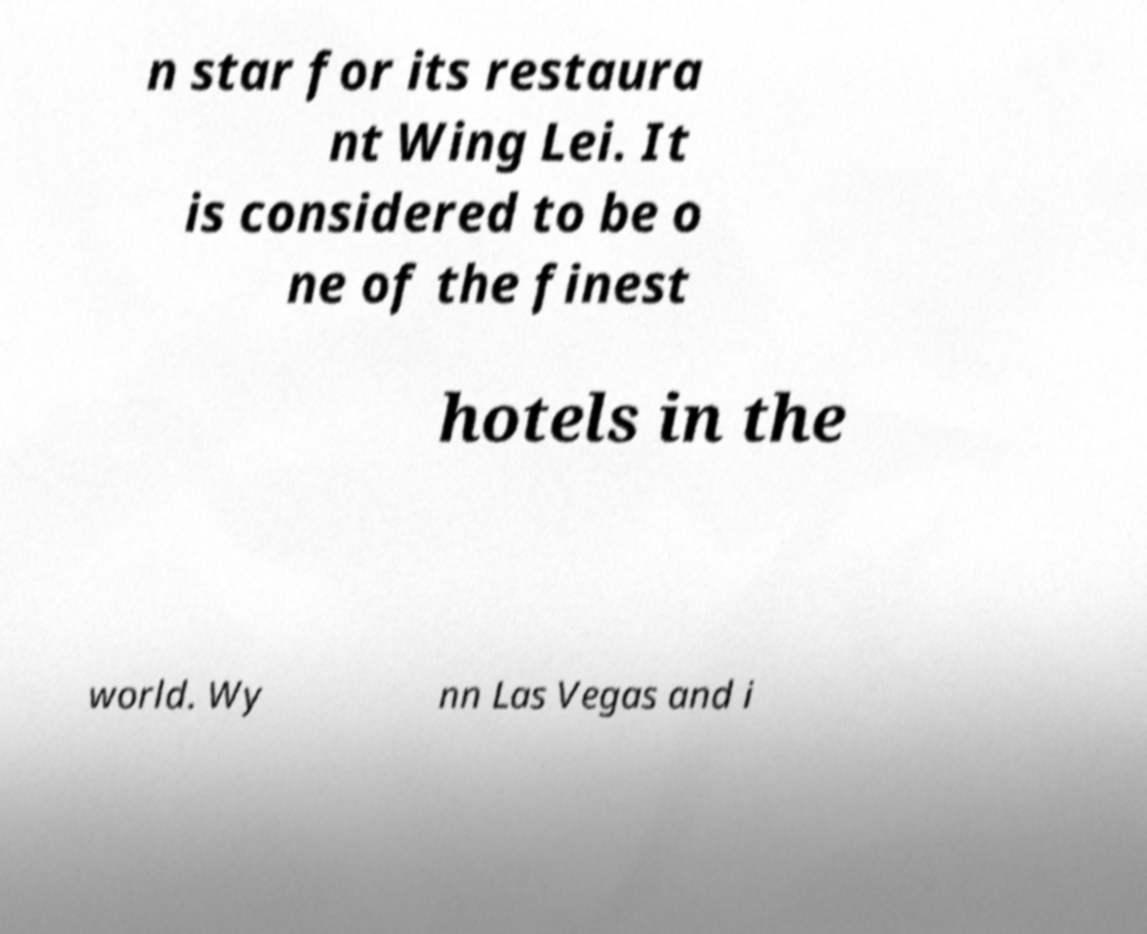Please identify and transcribe the text found in this image. n star for its restaura nt Wing Lei. It is considered to be o ne of the finest hotels in the world. Wy nn Las Vegas and i 